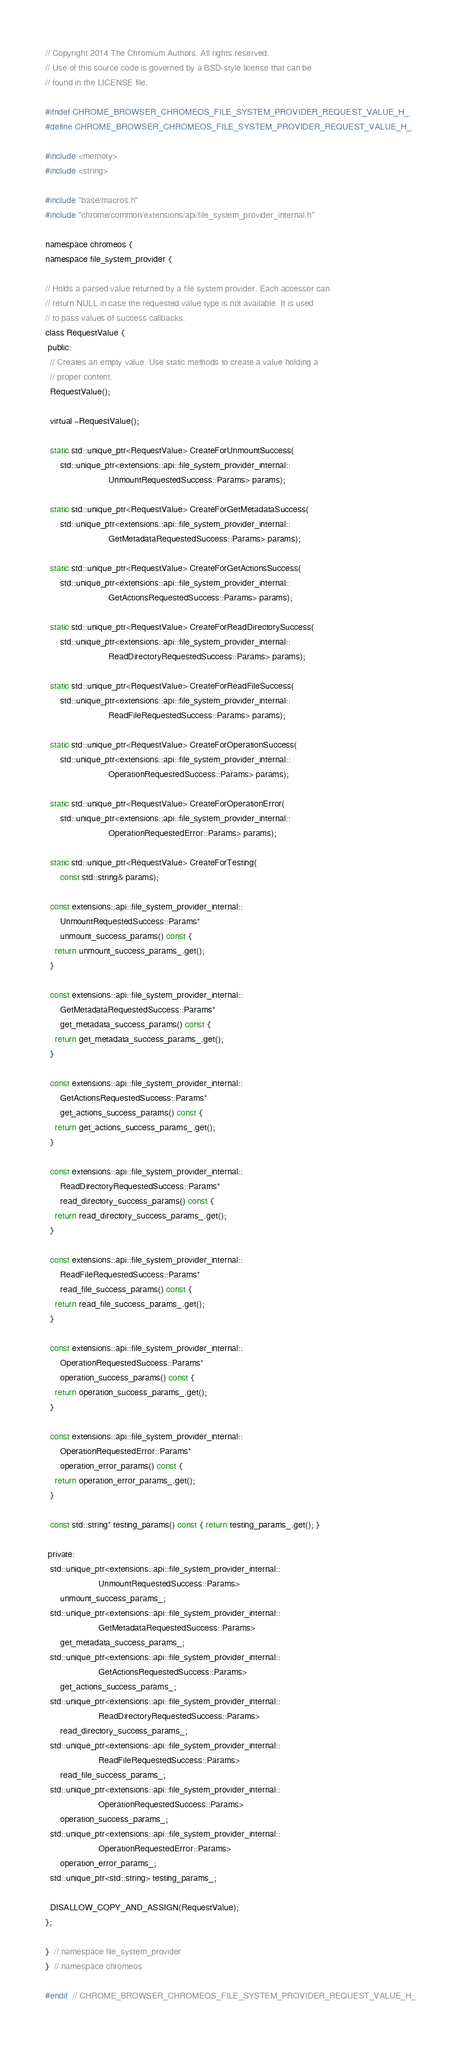<code> <loc_0><loc_0><loc_500><loc_500><_C_>// Copyright 2014 The Chromium Authors. All rights reserved.
// Use of this source code is governed by a BSD-style license that can be
// found in the LICENSE file.

#ifndef CHROME_BROWSER_CHROMEOS_FILE_SYSTEM_PROVIDER_REQUEST_VALUE_H_
#define CHROME_BROWSER_CHROMEOS_FILE_SYSTEM_PROVIDER_REQUEST_VALUE_H_

#include <memory>
#include <string>

#include "base/macros.h"
#include "chrome/common/extensions/api/file_system_provider_internal.h"

namespace chromeos {
namespace file_system_provider {

// Holds a parsed value returned by a file system provider. Each accessor can
// return NULL in case the requested value type is not available. It is used
// to pass values of success callbacks.
class RequestValue {
 public:
  // Creates an empty value. Use static methods to create a value holding a
  // proper content.
  RequestValue();

  virtual ~RequestValue();

  static std::unique_ptr<RequestValue> CreateForUnmountSuccess(
      std::unique_ptr<extensions::api::file_system_provider_internal::
                          UnmountRequestedSuccess::Params> params);

  static std::unique_ptr<RequestValue> CreateForGetMetadataSuccess(
      std::unique_ptr<extensions::api::file_system_provider_internal::
                          GetMetadataRequestedSuccess::Params> params);

  static std::unique_ptr<RequestValue> CreateForGetActionsSuccess(
      std::unique_ptr<extensions::api::file_system_provider_internal::
                          GetActionsRequestedSuccess::Params> params);

  static std::unique_ptr<RequestValue> CreateForReadDirectorySuccess(
      std::unique_ptr<extensions::api::file_system_provider_internal::
                          ReadDirectoryRequestedSuccess::Params> params);

  static std::unique_ptr<RequestValue> CreateForReadFileSuccess(
      std::unique_ptr<extensions::api::file_system_provider_internal::
                          ReadFileRequestedSuccess::Params> params);

  static std::unique_ptr<RequestValue> CreateForOperationSuccess(
      std::unique_ptr<extensions::api::file_system_provider_internal::
                          OperationRequestedSuccess::Params> params);

  static std::unique_ptr<RequestValue> CreateForOperationError(
      std::unique_ptr<extensions::api::file_system_provider_internal::
                          OperationRequestedError::Params> params);

  static std::unique_ptr<RequestValue> CreateForTesting(
      const std::string& params);

  const extensions::api::file_system_provider_internal::
      UnmountRequestedSuccess::Params*
      unmount_success_params() const {
    return unmount_success_params_.get();
  }

  const extensions::api::file_system_provider_internal::
      GetMetadataRequestedSuccess::Params*
      get_metadata_success_params() const {
    return get_metadata_success_params_.get();
  }

  const extensions::api::file_system_provider_internal::
      GetActionsRequestedSuccess::Params*
      get_actions_success_params() const {
    return get_actions_success_params_.get();
  }

  const extensions::api::file_system_provider_internal::
      ReadDirectoryRequestedSuccess::Params*
      read_directory_success_params() const {
    return read_directory_success_params_.get();
  }

  const extensions::api::file_system_provider_internal::
      ReadFileRequestedSuccess::Params*
      read_file_success_params() const {
    return read_file_success_params_.get();
  }

  const extensions::api::file_system_provider_internal::
      OperationRequestedSuccess::Params*
      operation_success_params() const {
    return operation_success_params_.get();
  }

  const extensions::api::file_system_provider_internal::
      OperationRequestedError::Params*
      operation_error_params() const {
    return operation_error_params_.get();
  }

  const std::string* testing_params() const { return testing_params_.get(); }

 private:
  std::unique_ptr<extensions::api::file_system_provider_internal::
                      UnmountRequestedSuccess::Params>
      unmount_success_params_;
  std::unique_ptr<extensions::api::file_system_provider_internal::
                      GetMetadataRequestedSuccess::Params>
      get_metadata_success_params_;
  std::unique_ptr<extensions::api::file_system_provider_internal::
                      GetActionsRequestedSuccess::Params>
      get_actions_success_params_;
  std::unique_ptr<extensions::api::file_system_provider_internal::
                      ReadDirectoryRequestedSuccess::Params>
      read_directory_success_params_;
  std::unique_ptr<extensions::api::file_system_provider_internal::
                      ReadFileRequestedSuccess::Params>
      read_file_success_params_;
  std::unique_ptr<extensions::api::file_system_provider_internal::
                      OperationRequestedSuccess::Params>
      operation_success_params_;
  std::unique_ptr<extensions::api::file_system_provider_internal::
                      OperationRequestedError::Params>
      operation_error_params_;
  std::unique_ptr<std::string> testing_params_;

  DISALLOW_COPY_AND_ASSIGN(RequestValue);
};

}  // namespace file_system_provider
}  // namespace chromeos

#endif  // CHROME_BROWSER_CHROMEOS_FILE_SYSTEM_PROVIDER_REQUEST_VALUE_H_
</code> 